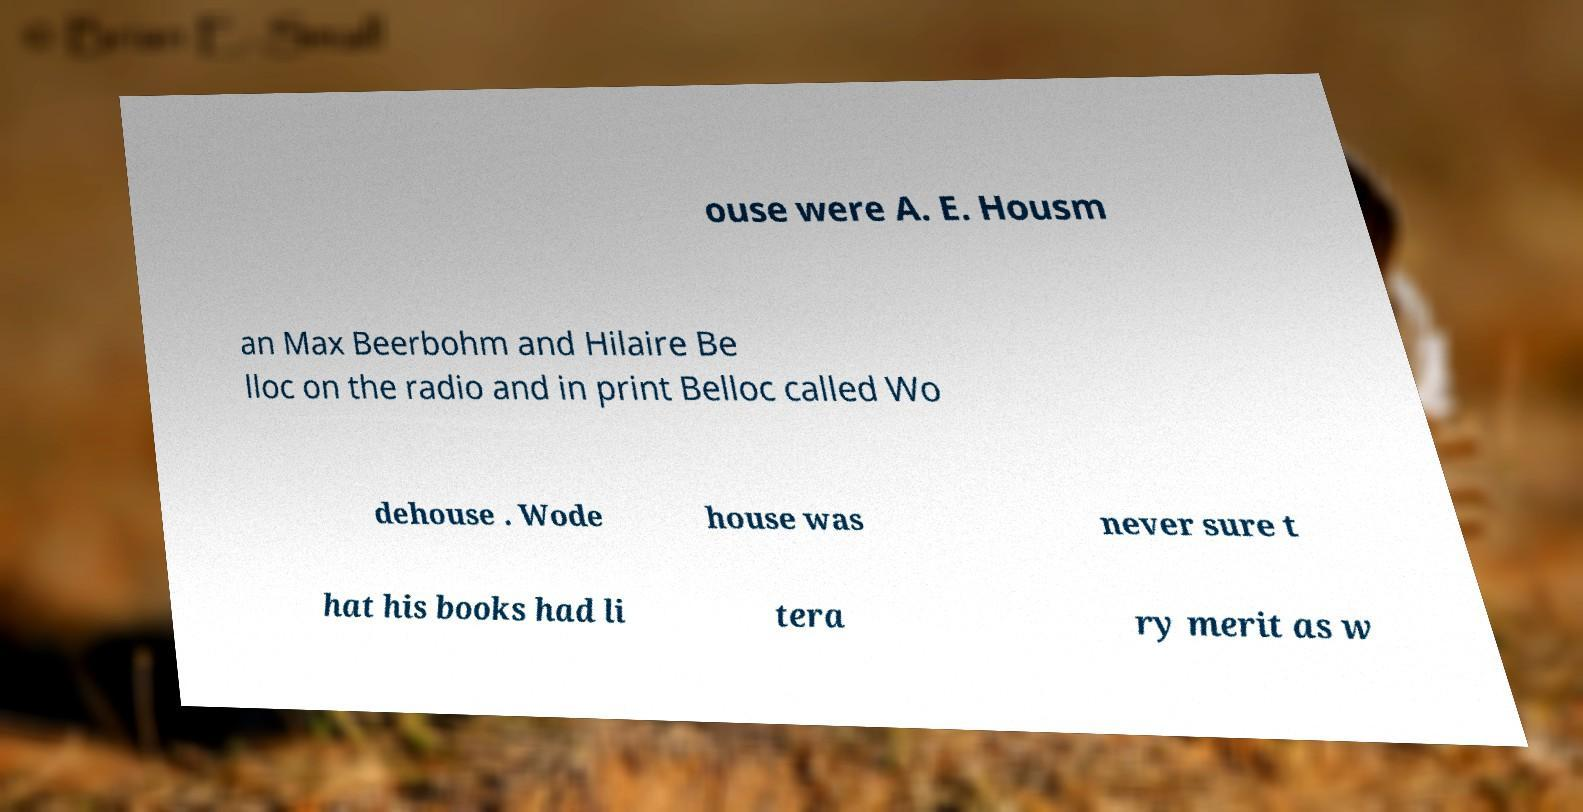Could you extract and type out the text from this image? ouse were A. E. Housm an Max Beerbohm and Hilaire Be lloc on the radio and in print Belloc called Wo dehouse . Wode house was never sure t hat his books had li tera ry merit as w 